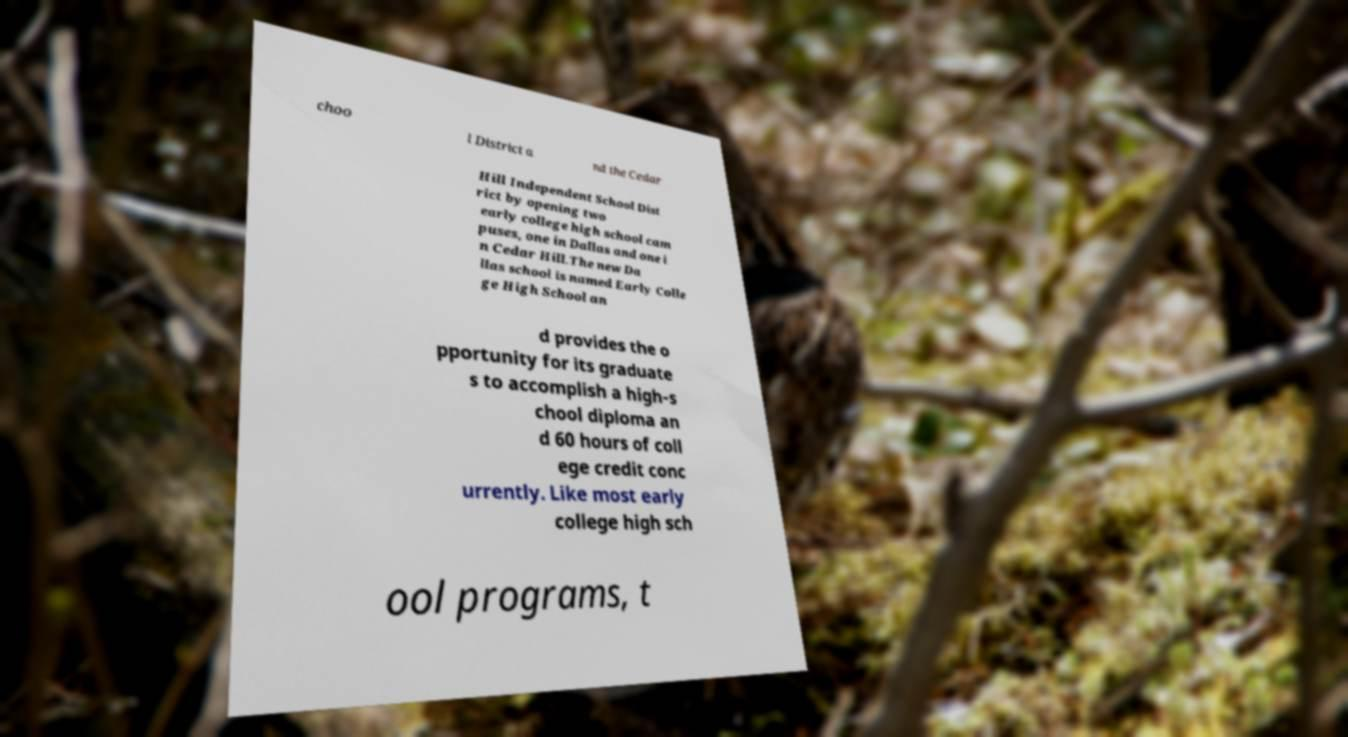Can you read and provide the text displayed in the image?This photo seems to have some interesting text. Can you extract and type it out for me? choo l District a nd the Cedar Hill Independent School Dist rict by opening two early college high school cam puses, one in Dallas and one i n Cedar Hill.The new Da llas school is named Early Colle ge High School an d provides the o pportunity for its graduate s to accomplish a high-s chool diploma an d 60 hours of coll ege credit conc urrently. Like most early college high sch ool programs, t 